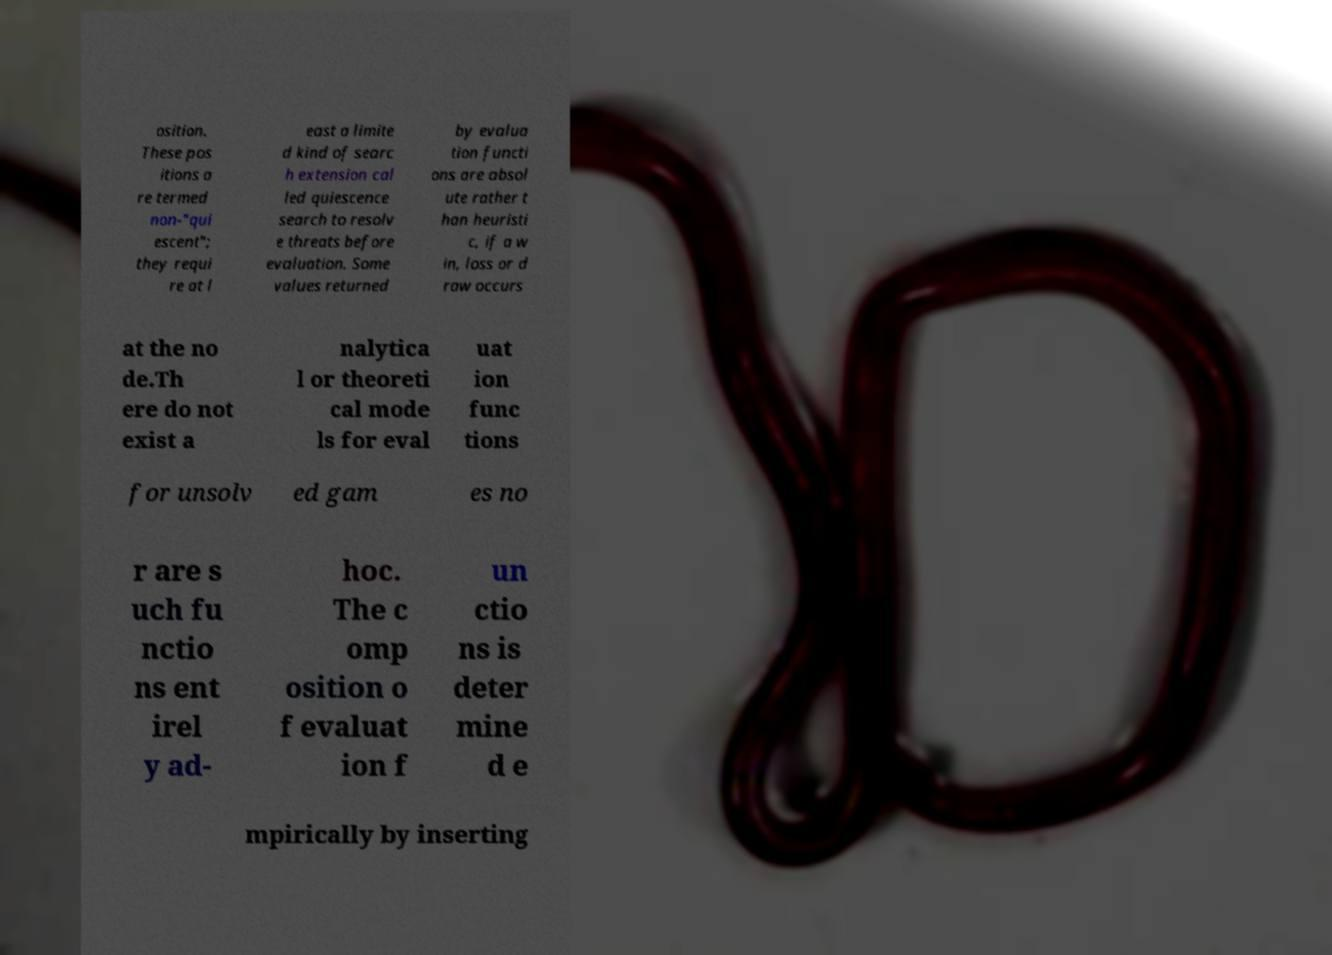Please read and relay the text visible in this image. What does it say? osition. These pos itions a re termed non-"qui escent"; they requi re at l east a limite d kind of searc h extension cal led quiescence search to resolv e threats before evaluation. Some values returned by evalua tion functi ons are absol ute rather t han heuristi c, if a w in, loss or d raw occurs at the no de.Th ere do not exist a nalytica l or theoreti cal mode ls for eval uat ion func tions for unsolv ed gam es no r are s uch fu nctio ns ent irel y ad- hoc. The c omp osition o f evaluat ion f un ctio ns is deter mine d e mpirically by inserting 